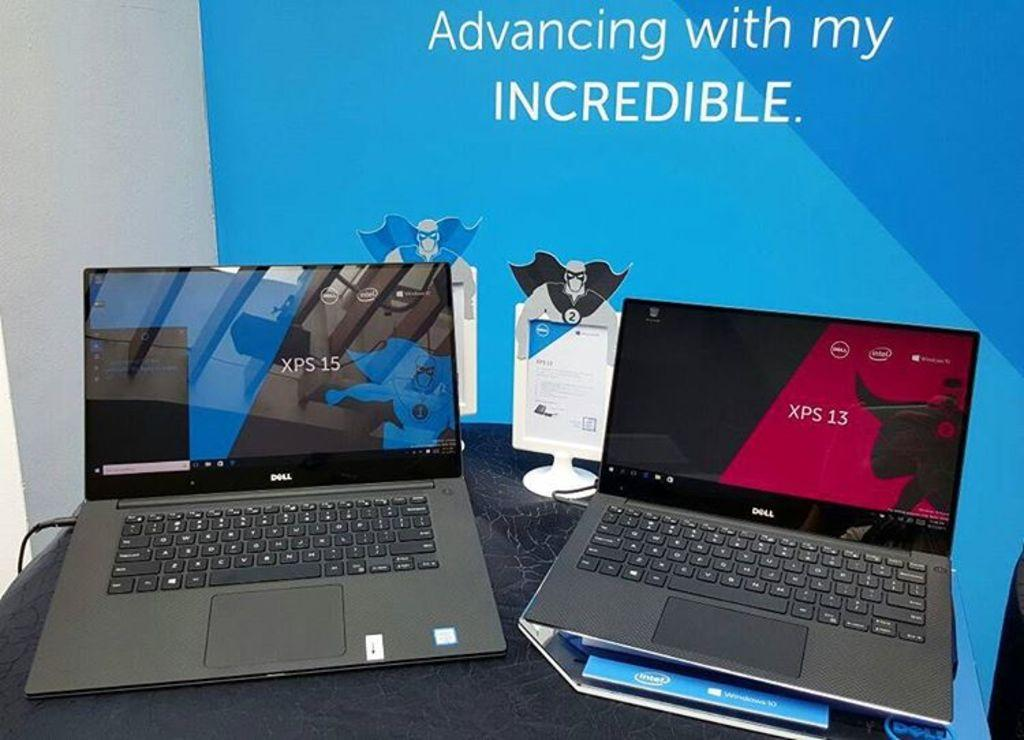Provide a one-sentence caption for the provided image. Two Dell laptops sit on a desk in front of a banner that says "Advancing with my INCREDIBLE". 